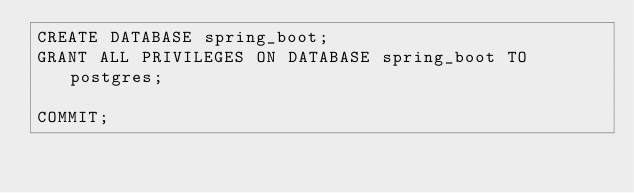<code> <loc_0><loc_0><loc_500><loc_500><_SQL_>CREATE DATABASE spring_boot;
GRANT ALL PRIVILEGES ON DATABASE spring_boot TO postgres;

COMMIT;</code> 